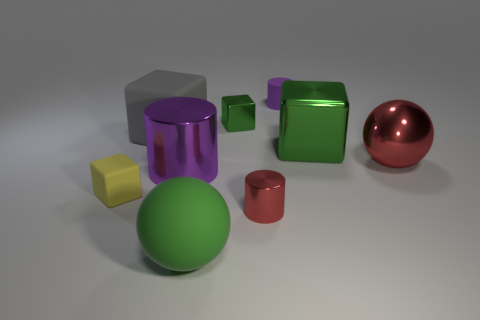Subtract all small green metal cubes. How many cubes are left? 3 How many purple cylinders must be subtracted to get 1 purple cylinders? 1 Subtract all gray blocks. How many blocks are left? 3 Subtract 2 spheres. How many spheres are left? 0 Subtract all purple cylinders. Subtract all yellow blocks. How many cylinders are left? 1 Subtract all brown cubes. How many yellow cylinders are left? 0 Subtract all tiny brown metallic spheres. Subtract all purple shiny things. How many objects are left? 8 Add 2 tiny shiny cubes. How many tiny shiny cubes are left? 3 Add 9 big gray rubber objects. How many big gray rubber objects exist? 10 Add 1 cyan cylinders. How many objects exist? 10 